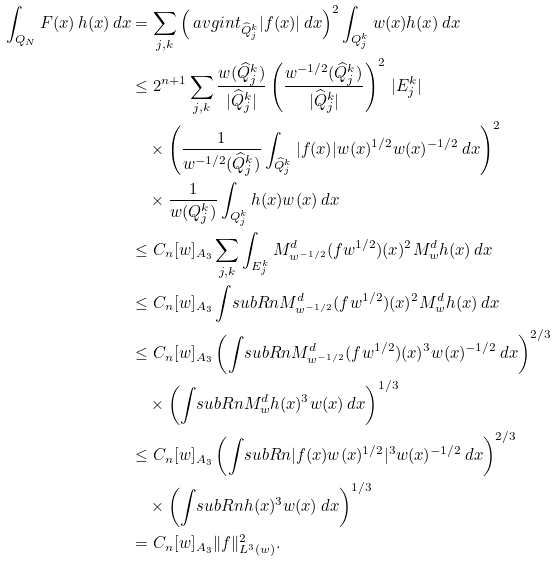Convert formula to latex. <formula><loc_0><loc_0><loc_500><loc_500>\int _ { Q _ { N } } F ( x ) \, h ( x ) \, d x & = \sum _ { j , k } \left ( \ a v g i n t _ { \widehat { Q } _ { j } ^ { k } } | f ( x ) | \, d x \right ) ^ { 2 } \int _ { Q _ { j } ^ { k } } w ( x ) h ( x ) \, d x \\ & \leq 2 ^ { n + 1 } \sum _ { j , k } \frac { w ( \widehat { Q } _ { j } ^ { k } ) } { | \widehat { Q } _ { j } ^ { k } | } \left ( \frac { w ^ { - 1 / 2 } ( \widehat { Q } _ { j } ^ { k } ) } { | \widehat { Q } _ { j } ^ { k } | } \right ) ^ { 2 } \, | E _ { j } ^ { k } | \\ & \quad \times \left ( \frac { 1 } { w ^ { - 1 / 2 } ( \widehat { Q } _ { j } ^ { k } ) } \int _ { \widehat { Q } _ { j } ^ { k } } | f ( x ) | w ( x ) ^ { 1 / 2 } w ( x ) ^ { - 1 / 2 } \, d x \right ) ^ { 2 } \\ & \quad \times \frac { 1 } { w ( Q _ { j } ^ { k } ) } \int _ { Q _ { j } ^ { k } } h ( x ) w ( x ) \, d x \\ & \leq C _ { n } [ w ] _ { A _ { 3 } } \sum _ { j , k } \int _ { E _ { j } ^ { k } } M ^ { d } _ { w ^ { - 1 / 2 } } ( f w ^ { 1 / 2 } ) ( x ) ^ { 2 } M ^ { d } _ { w } h ( x ) \, d x \\ & \leq C _ { n } [ w ] _ { A _ { 3 } } \int _ { \ } s u b R n M ^ { d } _ { w ^ { - 1 / 2 } } ( f w ^ { 1 / 2 } ) ( x ) ^ { 2 } M ^ { d } _ { w } h ( x ) \, d x \\ & \leq C _ { n } [ w ] _ { A _ { 3 } } \left ( \int _ { \ } s u b R n M ^ { d } _ { w ^ { - 1 / 2 } } ( f w ^ { 1 / 2 } ) ( x ) ^ { 3 } w ( x ) ^ { - 1 / 2 } \, d x \right ) ^ { 2 / 3 } \\ & \quad \times \left ( \int _ { \ } s u b R n M ^ { d } _ { w } h ( x ) ^ { 3 } w ( x ) \, d x \right ) ^ { 1 / 3 } \\ & \leq C _ { n } [ w ] _ { A _ { 3 } } \left ( \int _ { \ } s u b R n | f ( x ) w ( x ) ^ { 1 / 2 } | ^ { 3 } w ( x ) ^ { - 1 / 2 } \, d x \right ) ^ { 2 / 3 } \\ & \quad \times \left ( \int _ { \ } s u b R n h ( x ) ^ { 3 } w ( x ) \, d x \right ) ^ { 1 / 3 } \\ & = C _ { n } [ w ] _ { A _ { 3 } } \| f \| _ { L ^ { 3 } ( w ) } ^ { 2 } .</formula> 